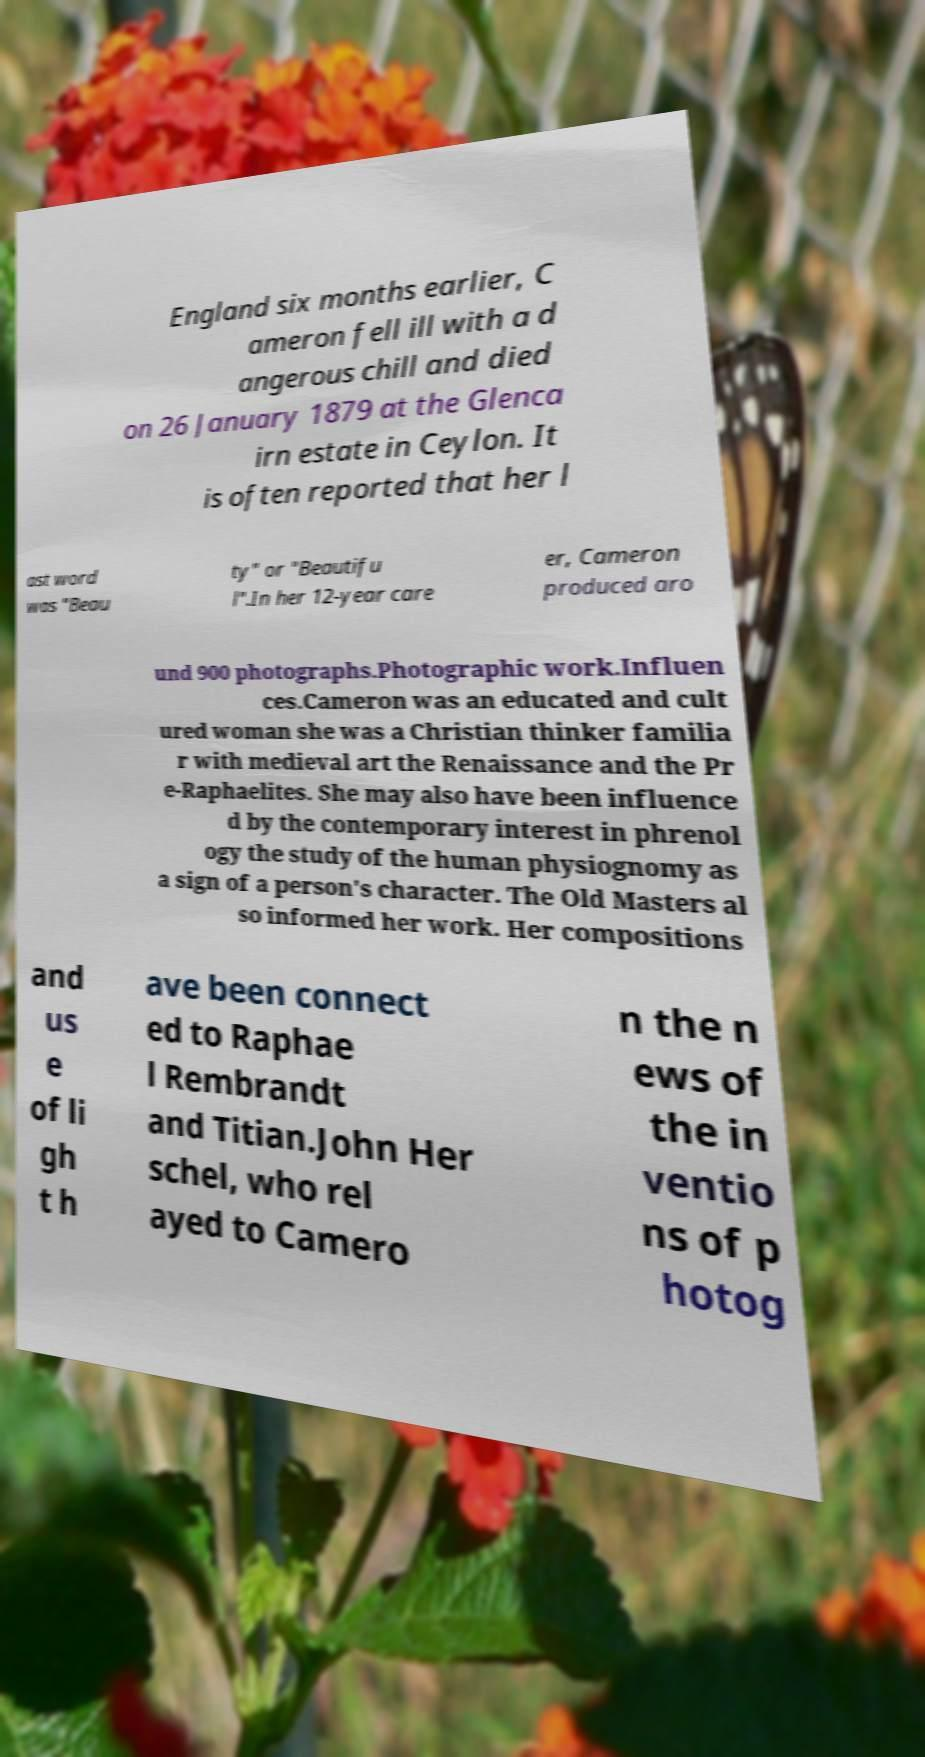There's text embedded in this image that I need extracted. Can you transcribe it verbatim? England six months earlier, C ameron fell ill with a d angerous chill and died on 26 January 1879 at the Glenca irn estate in Ceylon. It is often reported that her l ast word was "Beau ty" or "Beautifu l".In her 12-year care er, Cameron produced aro und 900 photographs.Photographic work.Influen ces.Cameron was an educated and cult ured woman she was a Christian thinker familia r with medieval art the Renaissance and the Pr e-Raphaelites. She may also have been influence d by the contemporary interest in phrenol ogy the study of the human physiognomy as a sign of a person's character. The Old Masters al so informed her work. Her compositions and us e of li gh t h ave been connect ed to Raphae l Rembrandt and Titian.John Her schel, who rel ayed to Camero n the n ews of the in ventio ns of p hotog 